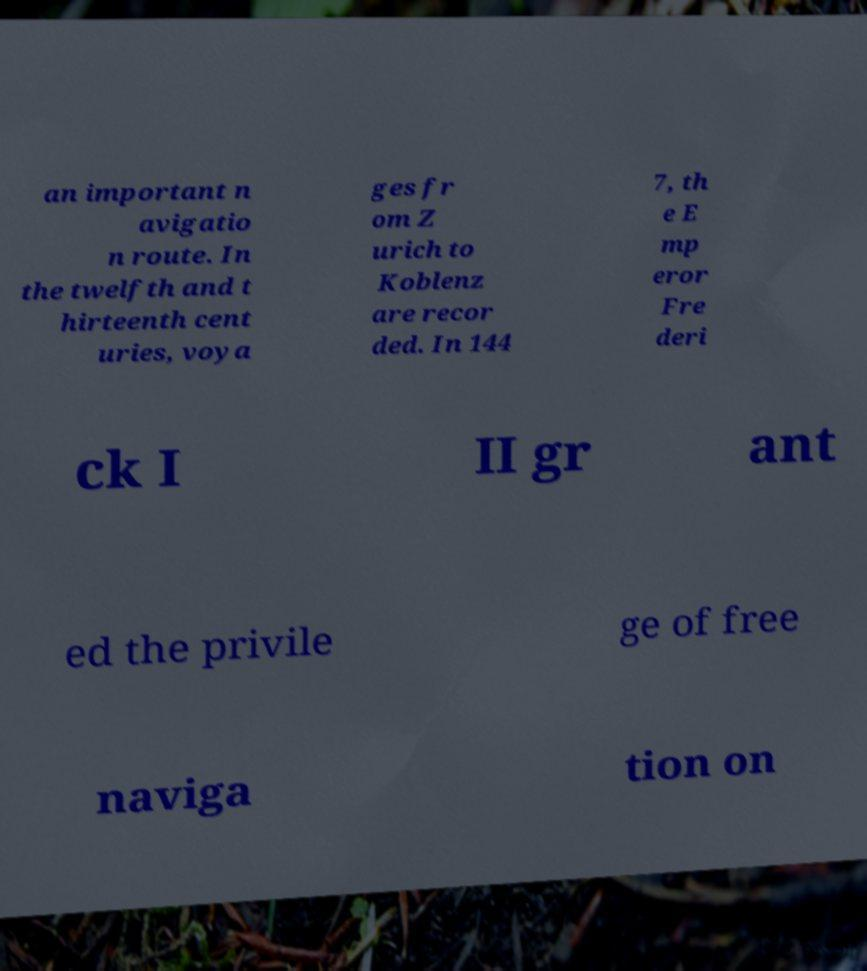Please read and relay the text visible in this image. What does it say? an important n avigatio n route. In the twelfth and t hirteenth cent uries, voya ges fr om Z urich to Koblenz are recor ded. In 144 7, th e E mp eror Fre deri ck I II gr ant ed the privile ge of free naviga tion on 